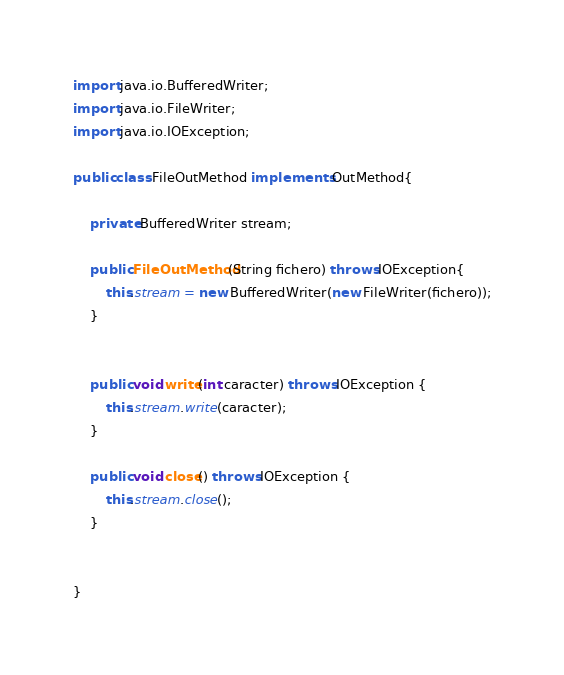<code> <loc_0><loc_0><loc_500><loc_500><_Java_>import java.io.BufferedWriter;
import java.io.FileWriter;
import java.io.IOException;

public class FileOutMethod implements OutMethod{

	private BufferedWriter stream;
	
	public FileOutMethod(String fichero) throws IOException{
		this.stream = new BufferedWriter(new FileWriter(fichero));
	}
	

	public void write(int caracter) throws IOException {
		this.stream.write(caracter);
	}

	public void close() throws IOException {
		this.stream.close();
	}
	
	
}
</code> 